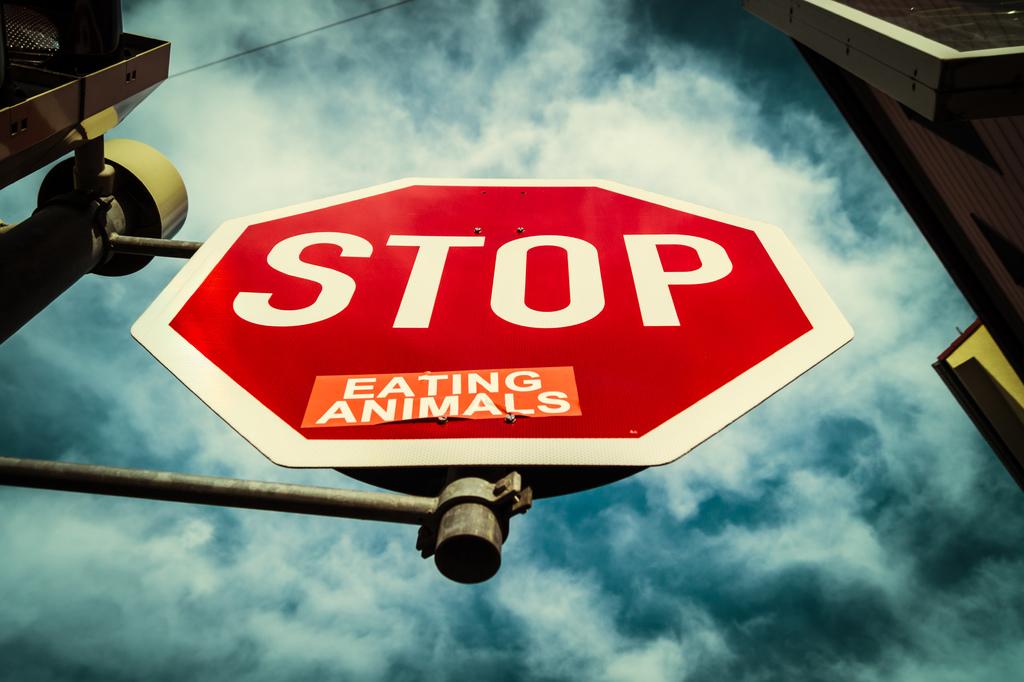What should stop being eaten?
Your answer should be very brief. Animals. 